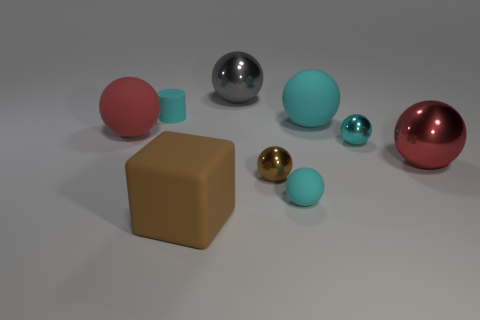Is there any other thing that is the same size as the cyan cylinder?
Your answer should be compact. Yes. There is a rubber object that is both in front of the cyan shiny sphere and behind the cube; what size is it?
Offer a very short reply. Small. There is a cyan metal object; what shape is it?
Give a very brief answer. Sphere. How many objects are either big brown blocks or red spheres that are on the left side of the brown cube?
Your response must be concise. 2. Do the matte ball left of the gray thing and the small rubber ball have the same color?
Offer a terse response. No. The metal ball that is behind the red metal object and on the left side of the tiny cyan metal sphere is what color?
Provide a succinct answer. Gray. What material is the tiny cyan sphere left of the large cyan thing?
Offer a very short reply. Rubber. How big is the gray ball?
Ensure brevity in your answer.  Large. What number of red things are either large matte balls or small shiny balls?
Your response must be concise. 1. There is a cylinder that is to the left of the small cyan matte object on the right side of the big brown matte object; how big is it?
Your response must be concise. Small. 